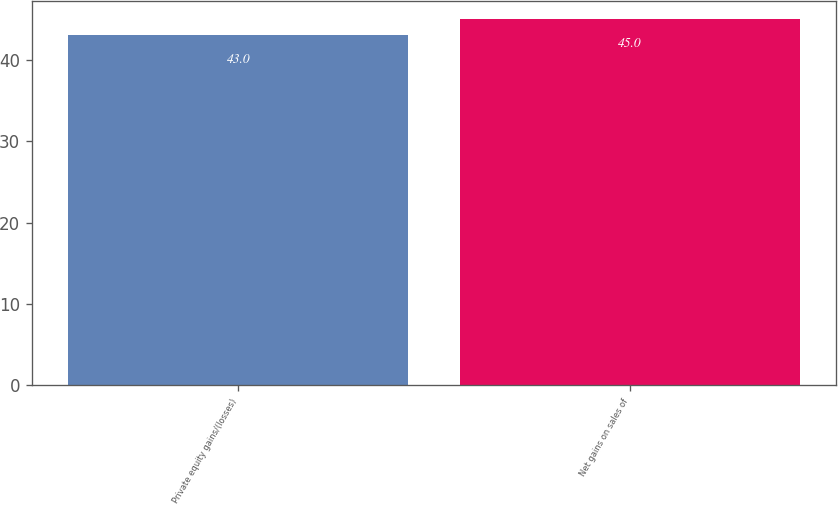Convert chart. <chart><loc_0><loc_0><loc_500><loc_500><bar_chart><fcel>Private equity gains/(losses)<fcel>Net gains on sales of<nl><fcel>43<fcel>45<nl></chart> 